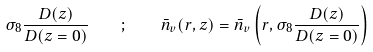Convert formula to latex. <formula><loc_0><loc_0><loc_500><loc_500>\sigma _ { 8 } \frac { D ( z ) } { D ( z = 0 ) } \quad ; \quad \bar { n } _ { v } ( r , z ) = \bar { n } _ { v } \left ( r , \sigma _ { 8 } \frac { D ( z ) } { D ( z = 0 ) } \right )</formula> 